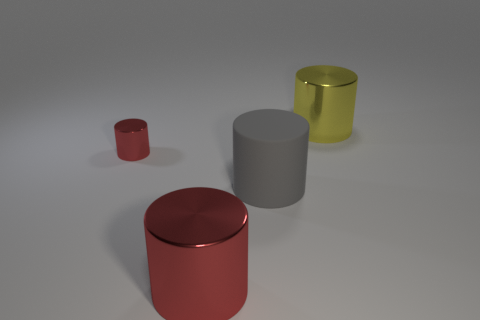Is the color of the small cylinder the same as the large matte object?
Make the answer very short. No. There is a big metallic cylinder behind the red cylinder behind the cylinder that is in front of the matte thing; what color is it?
Provide a succinct answer. Yellow. What number of big cylinders are behind the gray rubber object that is on the right side of the metallic cylinder in front of the gray cylinder?
Give a very brief answer. 1. Is there any other thing that is the same color as the big matte cylinder?
Your answer should be compact. No. Do the red object behind the gray object and the yellow object have the same size?
Offer a very short reply. No. How many large metallic things are to the right of the big metallic cylinder in front of the yellow metallic cylinder?
Make the answer very short. 1. There is a red cylinder behind the big metal cylinder on the left side of the yellow cylinder; is there a red cylinder on the right side of it?
Make the answer very short. Yes. What is the material of the tiny red object that is the same shape as the gray rubber thing?
Provide a succinct answer. Metal. Are there any other things that are made of the same material as the gray thing?
Your answer should be very brief. No. Are the big red cylinder and the cylinder that is on the right side of the big gray matte thing made of the same material?
Provide a short and direct response. Yes. 